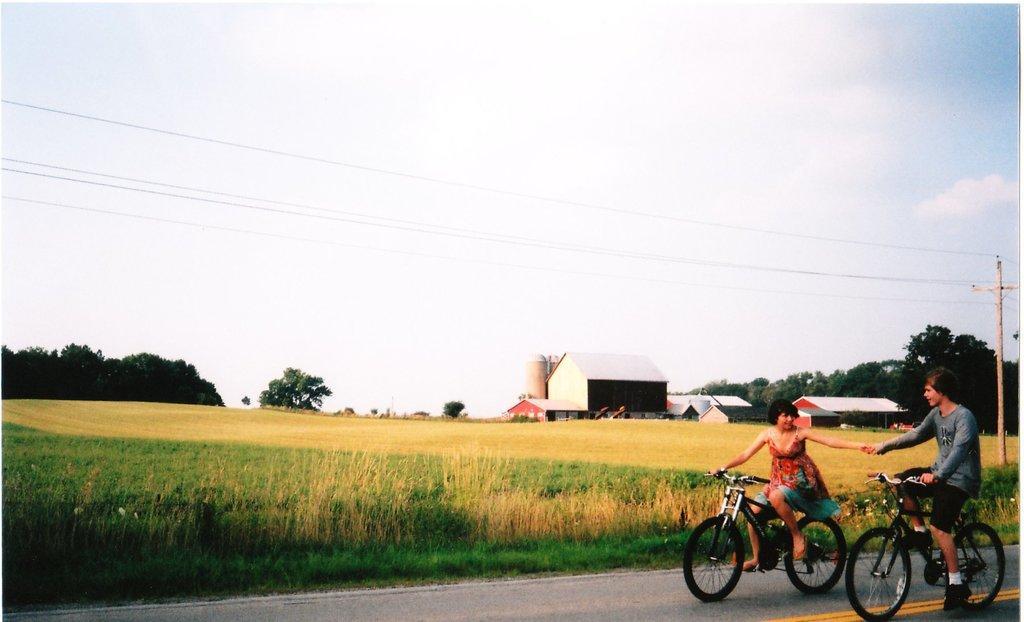Please provide a concise description of this image. In this image i can see a woman and a man riding a bicycle. In the background i can see a farm, a building, few trees, a electric pole and sky. 